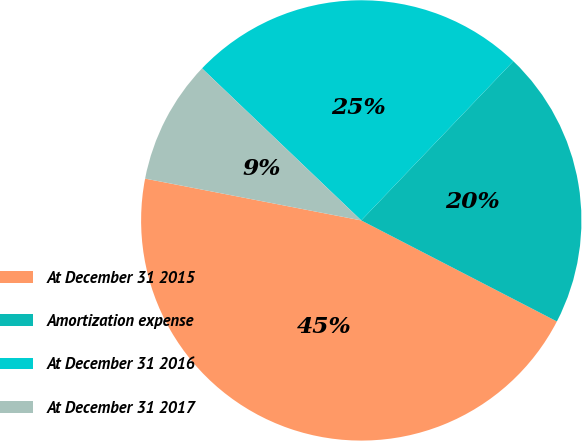<chart> <loc_0><loc_0><loc_500><loc_500><pie_chart><fcel>At December 31 2015<fcel>Amortization expense<fcel>At December 31 2016<fcel>At December 31 2017<nl><fcel>45.45%<fcel>20.45%<fcel>25.0%<fcel>9.09%<nl></chart> 